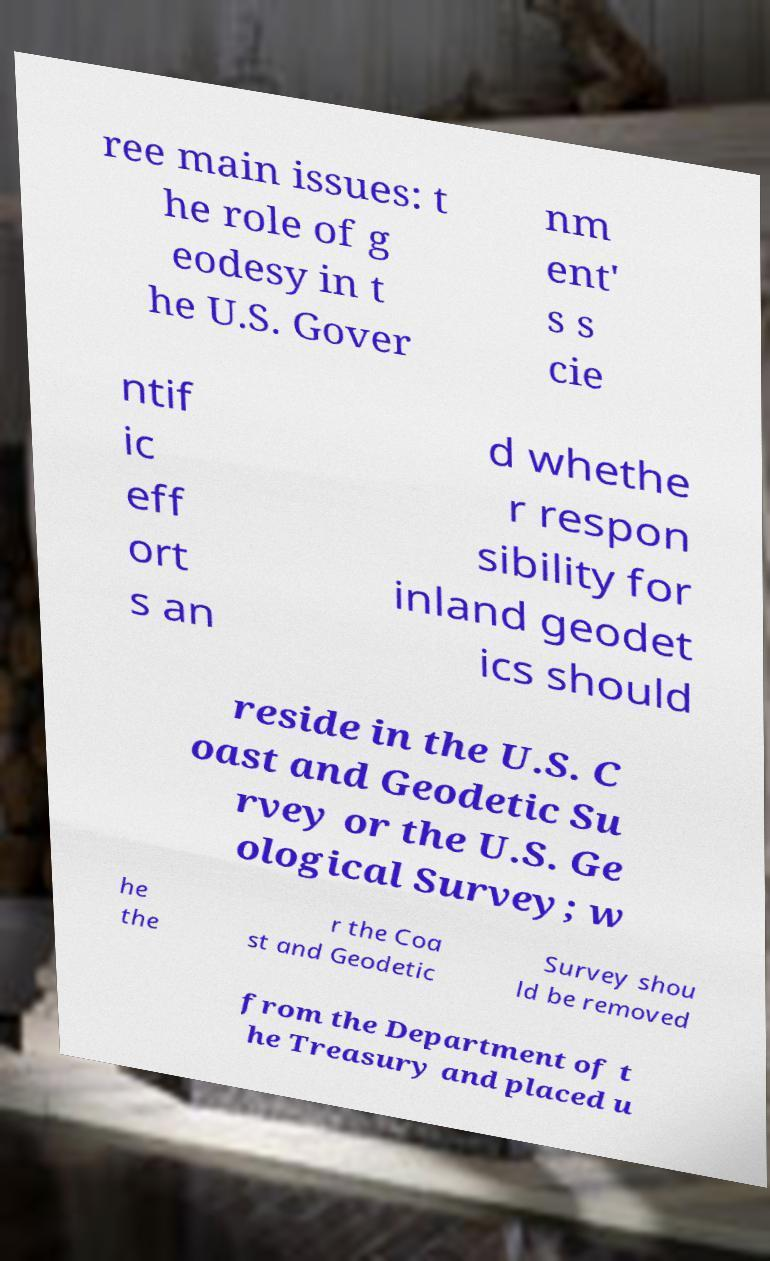What messages or text are displayed in this image? I need them in a readable, typed format. ree main issues: t he role of g eodesy in t he U.S. Gover nm ent' s s cie ntif ic eff ort s an d whethe r respon sibility for inland geodet ics should reside in the U.S. C oast and Geodetic Su rvey or the U.S. Ge ological Survey; w he the r the Coa st and Geodetic Survey shou ld be removed from the Department of t he Treasury and placed u 